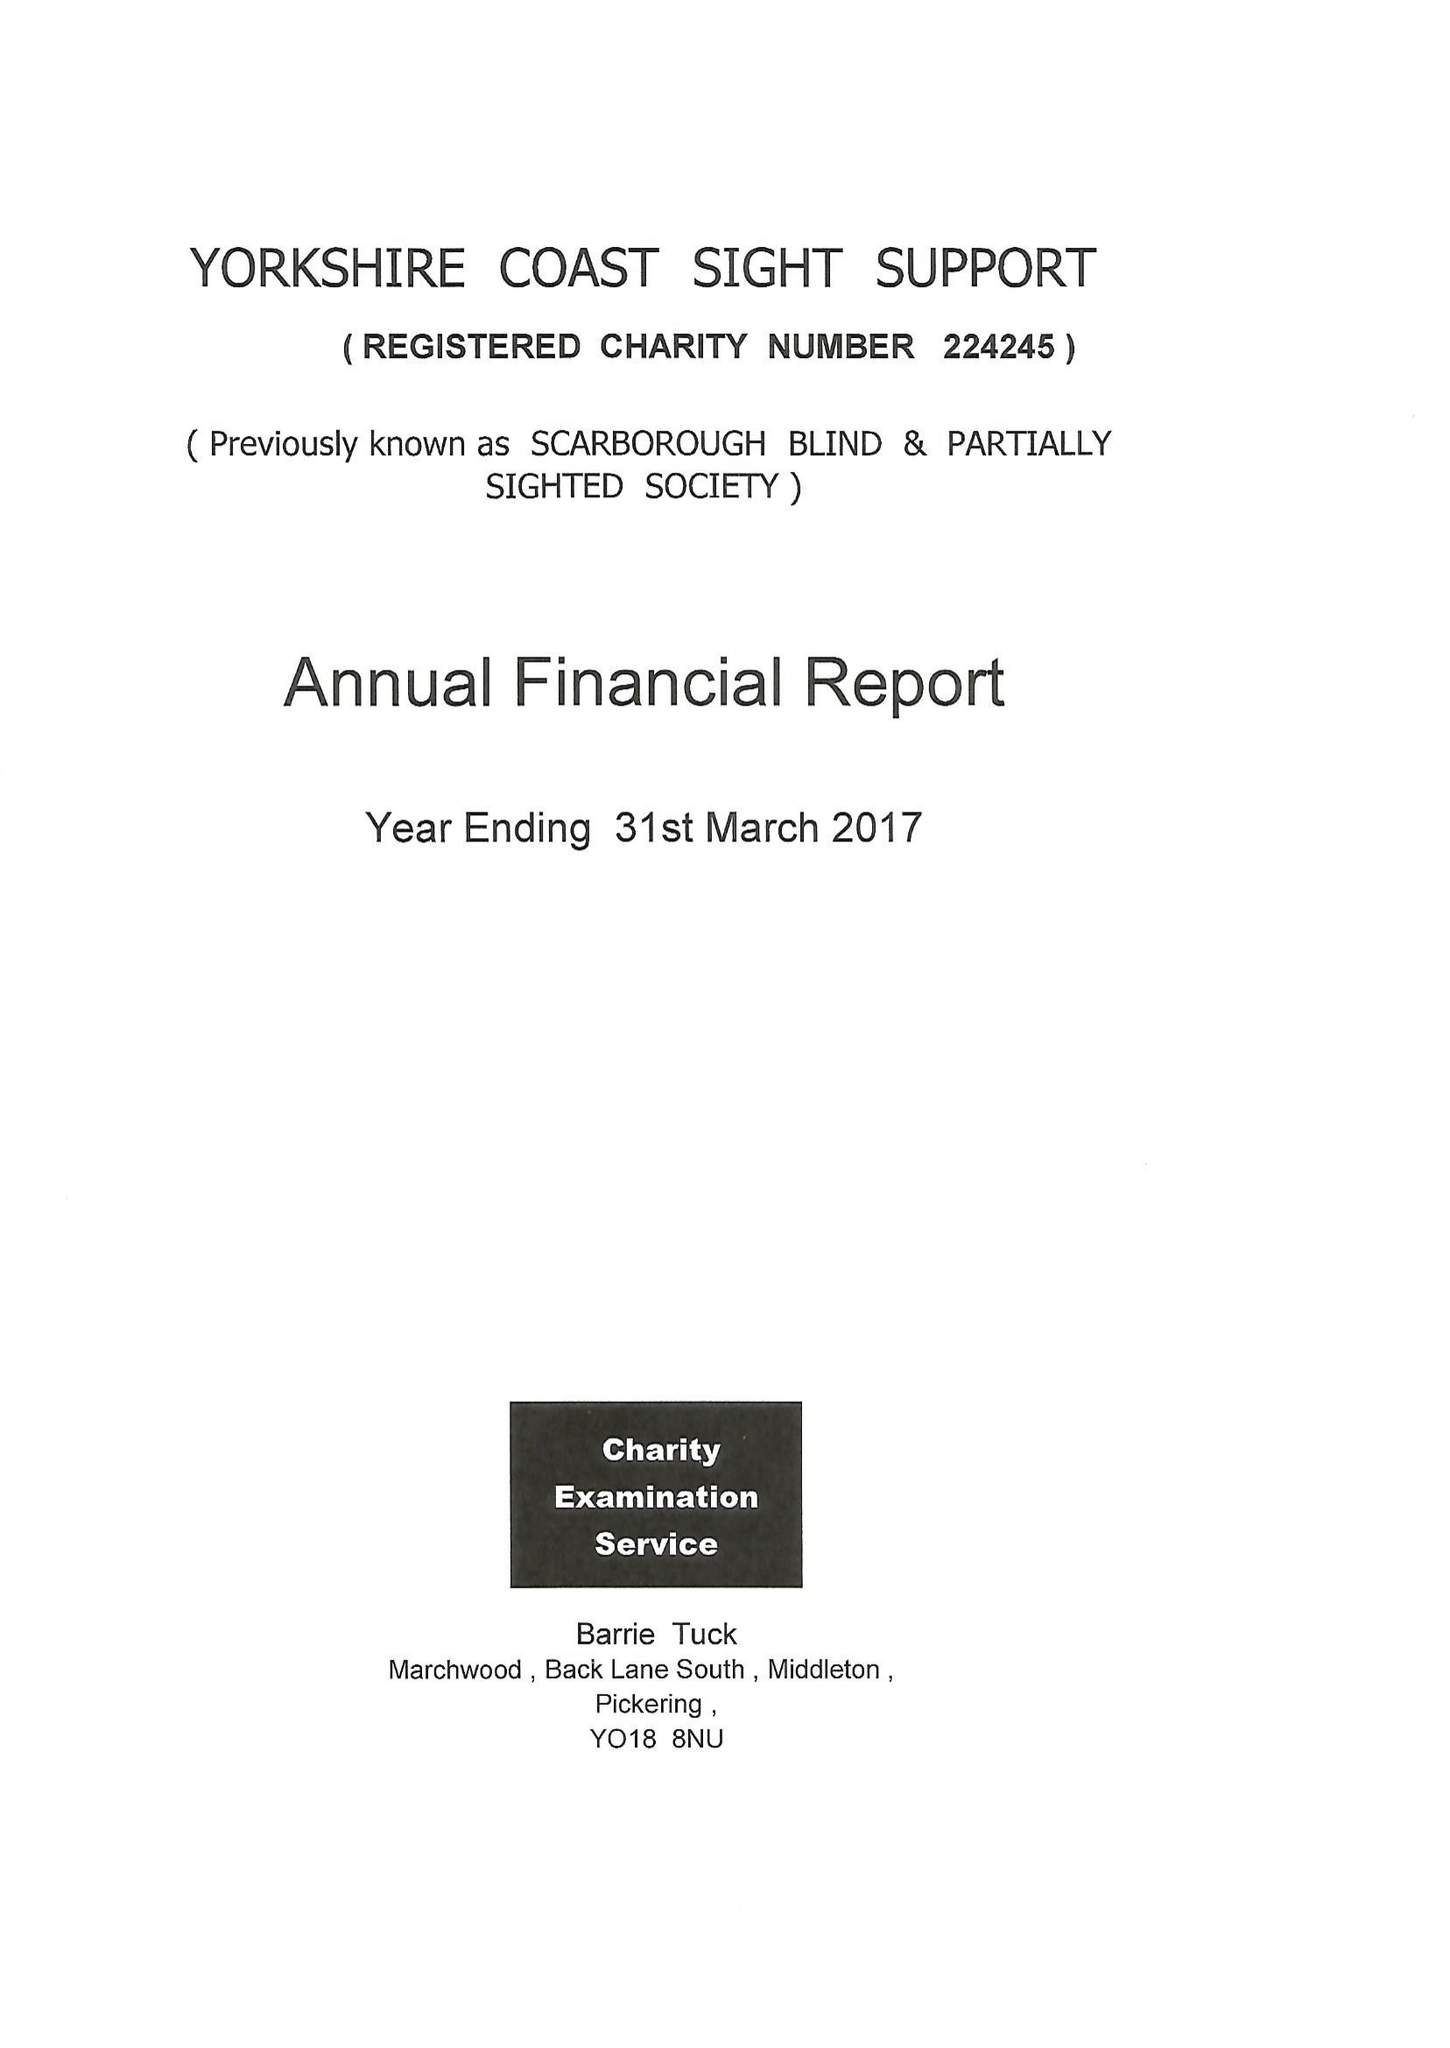What is the value for the report_date?
Answer the question using a single word or phrase. 2017-03-31 